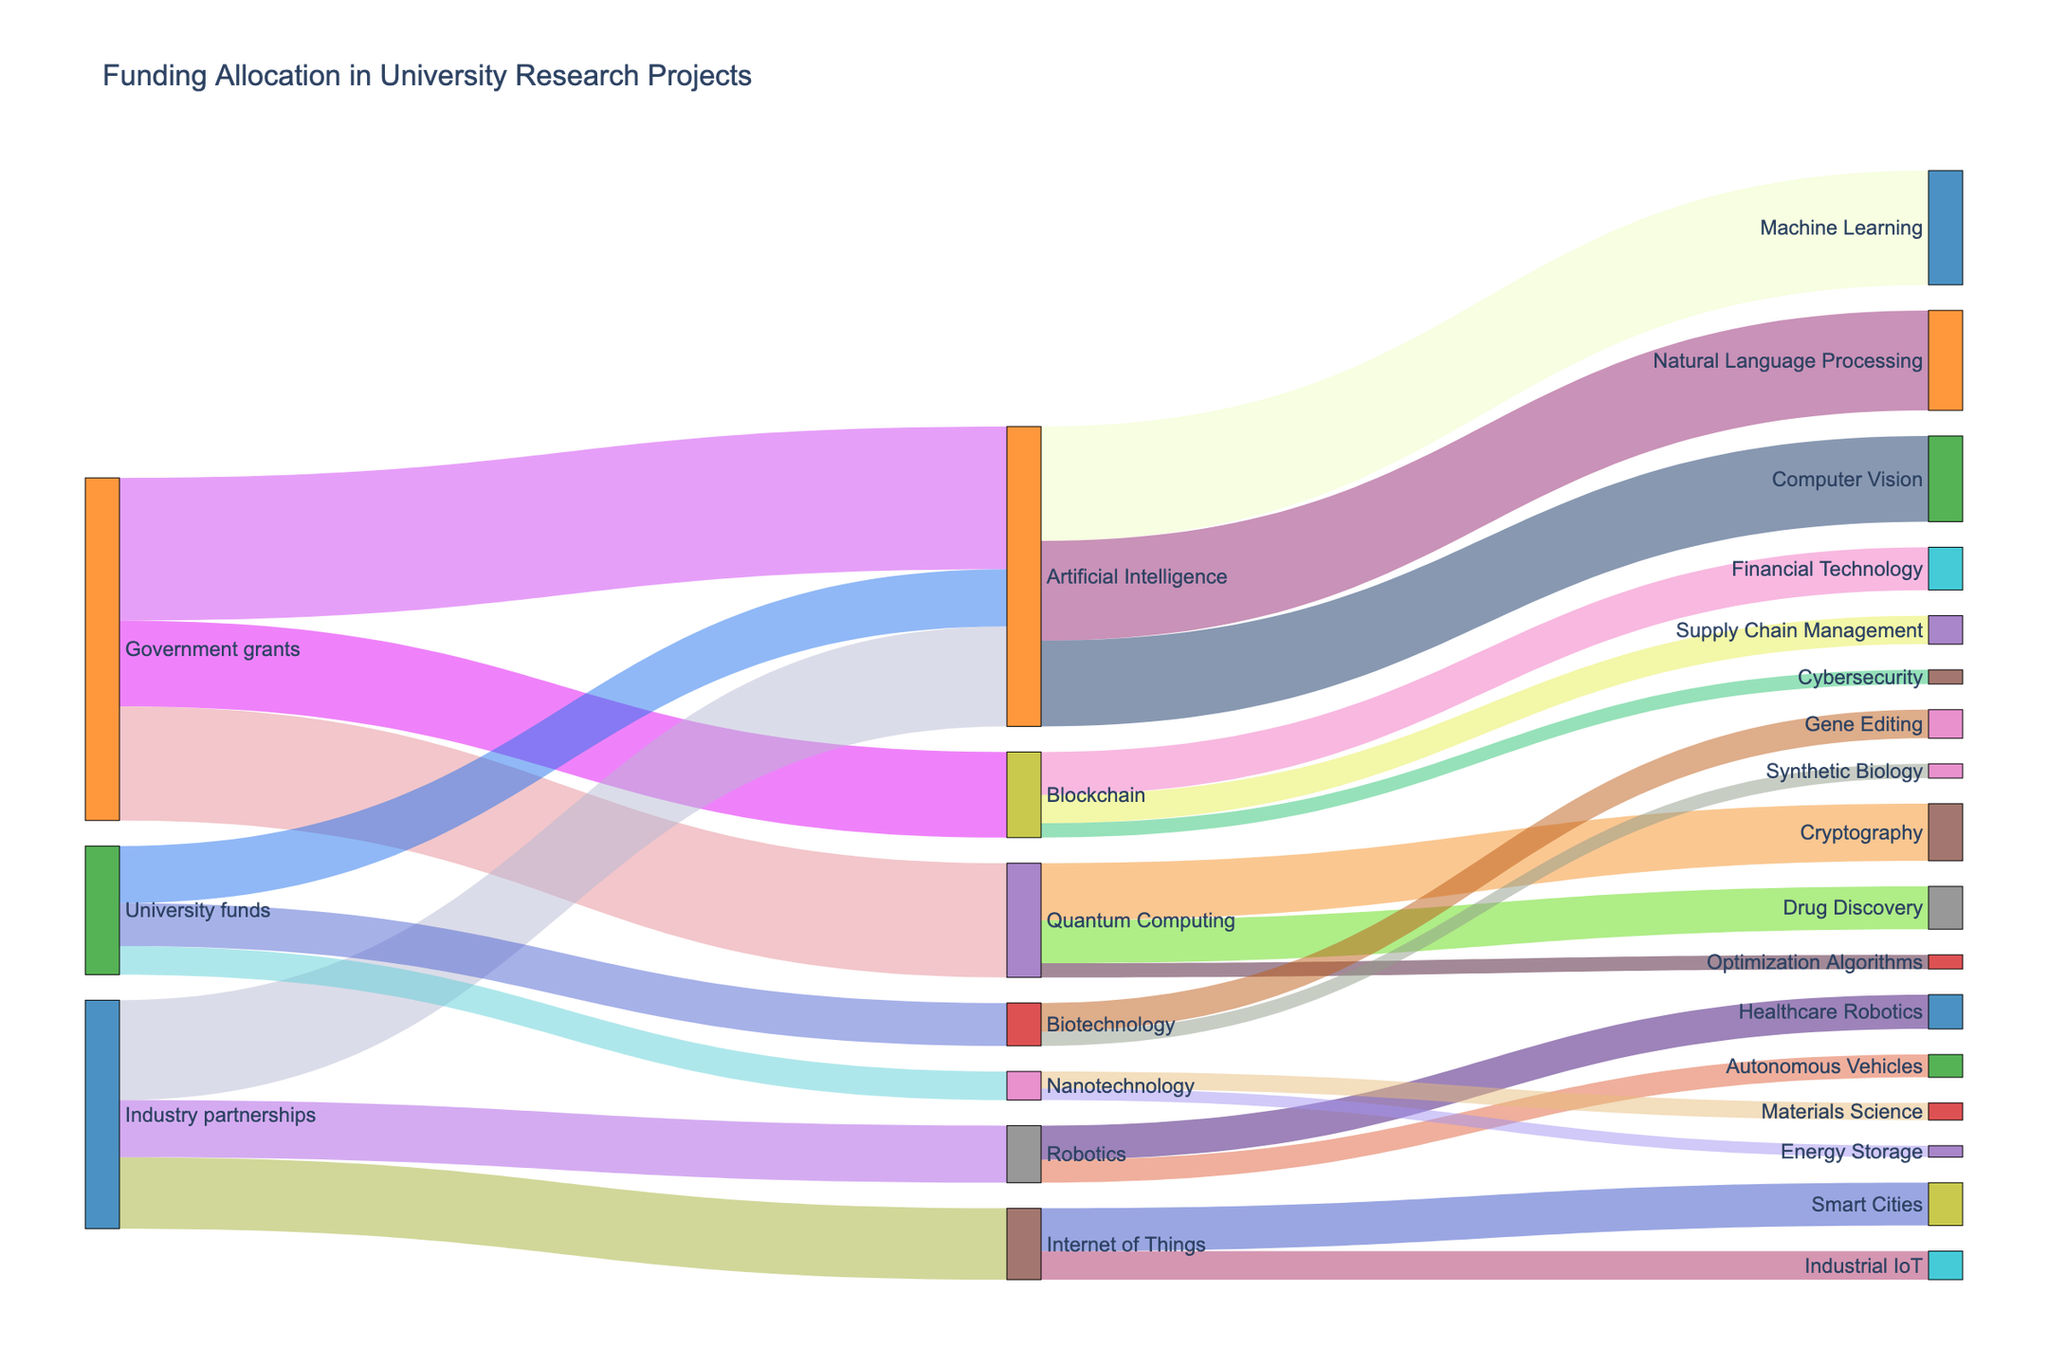What is the total funding allocated to Artificial Intelligence research projects? To find the total funding allocated to Artificial Intelligence research projects, sum all incoming flows to Artificial Intelligence. From the Sankey diagram, these are: Government grants (5,000,000), Industry partnerships (3,500,000), and University funds (2,000,000). Thus, the total funding is 5,000,000 + 3,500,000 + 2,000,000 = 10,500,000.
Answer: 10,500,000 Which research project received the highest funding from Government grants? On the Sankey diagram, check the links originating from Government grants. The allocations are as follows: Artificial Intelligence (5,000,000), Blockchain (3,000,000), and Quantum Computing (4,000,000). Thus, Artificial Intelligence received the highest funding.
Answer: Artificial Intelligence How much more funding does Robotics receive from Industry partnerships than from University funds? On the Sankey diagram, identify the funding amounts for Robotics from different sources. Industry partnerships allocated 2,000,000, while University funds allocated 0. The difference is 2,000,000 - 0 = 2,000,000.
Answer: 2,000,000 Between Machine Learning and Natural Language Processing, which sub-field of Artificial Intelligence received less funding and by how much? From the Sankey diagram, identify the funding amounts for Machine Learning (4,000,000) and Natural Language Processing (3,500,000). Natural Language Processing received less funding than Machine Learning. The difference is 4,000,000 - 3,500,000 = 500,000.
Answer: Natural Language Processing, 500,000 What percentage of the total funding to Quantum Computing is allocated to Drug Discovery? First, find the total funding received by Quantum Computing from all sources (4,000,000 from Government grants). Then, check the funding allocated to Drug Discovery (1,500,000). The percentage is calculated as \( (1,500,000 / 4,000,000) \times 100 \approx 37.5\% \).
Answer: 37.5% What is the combined funding provided by University funds to Biotechnology and Nanotechnology? From the Sankey diagram, University funds allocated 1,500,000 to Biotechnology and 1,000,000 to Nanotechnology. The combined funding is 1,500,000 + 1,000,000 = 2,500,000.
Answer: 2,500,000 Of the sub-fields in Blockchain, which received the lowest funding and how much was it? Check the Sankey diagram for Blockchain's sub-fields funding: Financial Technology (1,500,000), Supply Chain Management (1,000,000), and Cybersecurity (500,000). Cybersecurity received the lowest funding of 500,000.
Answer: Cybersecurity, 500,000 What is the amount of funding allocated to Healthcare Robotics? On the Sankey diagram, identify the link between Robotics and Healthcare Robotics. The allocated funding is 1,200,000.
Answer: 1,200,000 